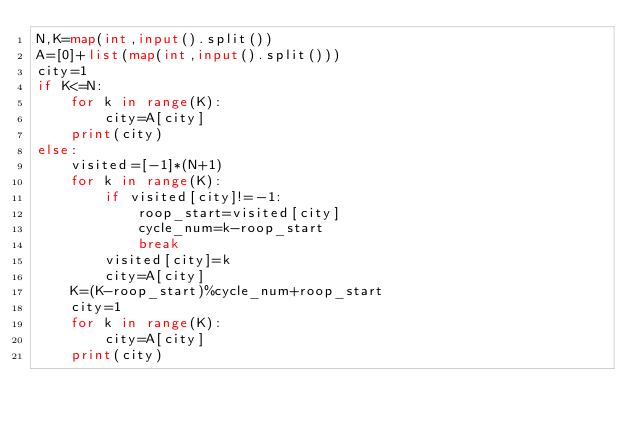<code> <loc_0><loc_0><loc_500><loc_500><_Python_>N,K=map(int,input().split())
A=[0]+list(map(int,input().split()))
city=1
if K<=N:
    for k in range(K):
        city=A[city]
    print(city)
else:
    visited=[-1]*(N+1)
    for k in range(K):
        if visited[city]!=-1:
            roop_start=visited[city]
            cycle_num=k-roop_start
            break
        visited[city]=k
        city=A[city]
    K=(K-roop_start)%cycle_num+roop_start
    city=1
    for k in range(K):
        city=A[city]
    print(city)</code> 